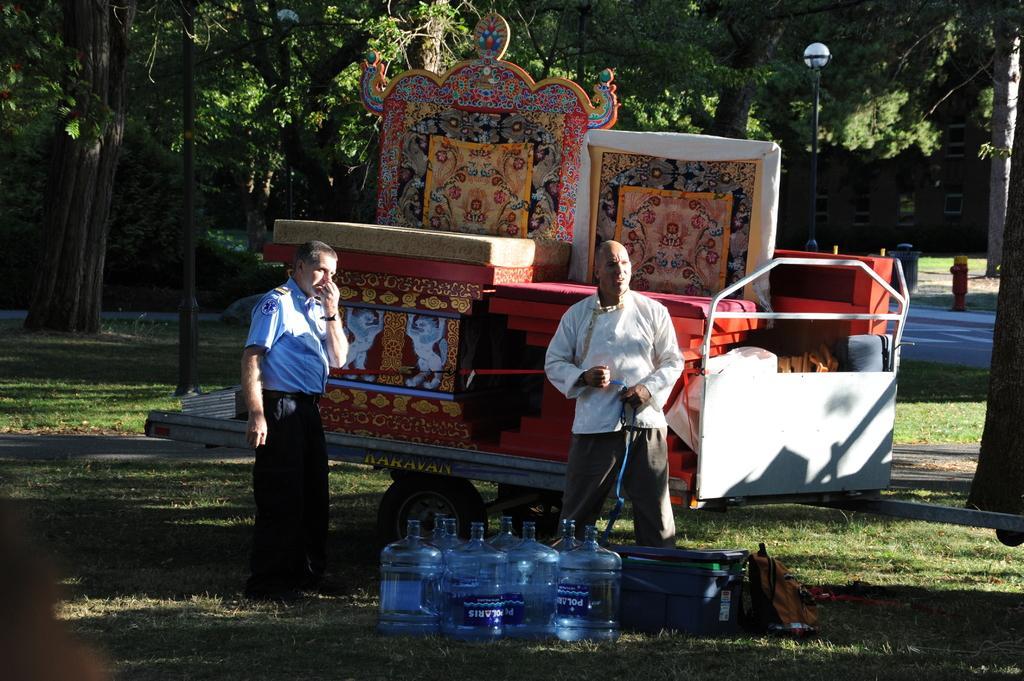How would you summarize this image in a sentence or two? In this image there is a trolley in which there are bed frames and beds on it. At the bottom there are water cans and bags beside them. On the left side there is a security officer standing on the ground. On the right side there is a man who is standing on the ground by holding the belt. In the background there are trees. 